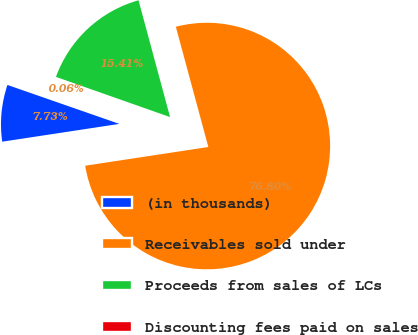Convert chart to OTSL. <chart><loc_0><loc_0><loc_500><loc_500><pie_chart><fcel>(in thousands)<fcel>Receivables sold under<fcel>Proceeds from sales of LCs<fcel>Discounting fees paid on sales<nl><fcel>7.73%<fcel>76.8%<fcel>15.41%<fcel>0.06%<nl></chart> 